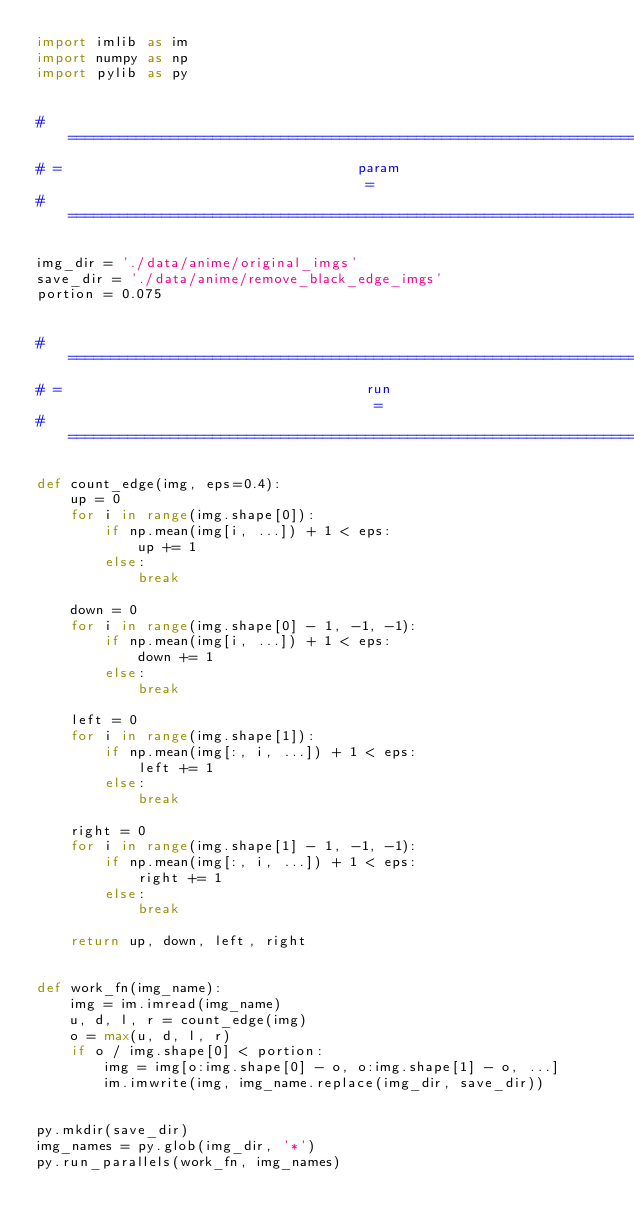<code> <loc_0><loc_0><loc_500><loc_500><_Python_>import imlib as im
import numpy as np
import pylib as py


# ==============================================================================
# =                                   param                                    =
# ==============================================================================

img_dir = './data/anime/original_imgs'
save_dir = './data/anime/remove_black_edge_imgs'
portion = 0.075


# ==============================================================================
# =                                    run                                     =
# ==============================================================================

def count_edge(img, eps=0.4):
    up = 0
    for i in range(img.shape[0]):
        if np.mean(img[i, ...]) + 1 < eps:
            up += 1
        else:
            break

    down = 0
    for i in range(img.shape[0] - 1, -1, -1):
        if np.mean(img[i, ...]) + 1 < eps:
            down += 1
        else:
            break

    left = 0
    for i in range(img.shape[1]):
        if np.mean(img[:, i, ...]) + 1 < eps:
            left += 1
        else:
            break

    right = 0
    for i in range(img.shape[1] - 1, -1, -1):
        if np.mean(img[:, i, ...]) + 1 < eps:
            right += 1
        else:
            break

    return up, down, left, right


def work_fn(img_name):
    img = im.imread(img_name)
    u, d, l, r = count_edge(img)
    o = max(u, d, l, r)
    if o / img.shape[0] < portion:
        img = img[o:img.shape[0] - o, o:img.shape[1] - o, ...]
        im.imwrite(img, img_name.replace(img_dir, save_dir))


py.mkdir(save_dir)
img_names = py.glob(img_dir, '*')
py.run_parallels(work_fn, img_names)
</code> 